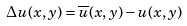<formula> <loc_0><loc_0><loc_500><loc_500>\Delta u ( x , y ) = \overline { u } ( x , y ) - u ( x , y )</formula> 